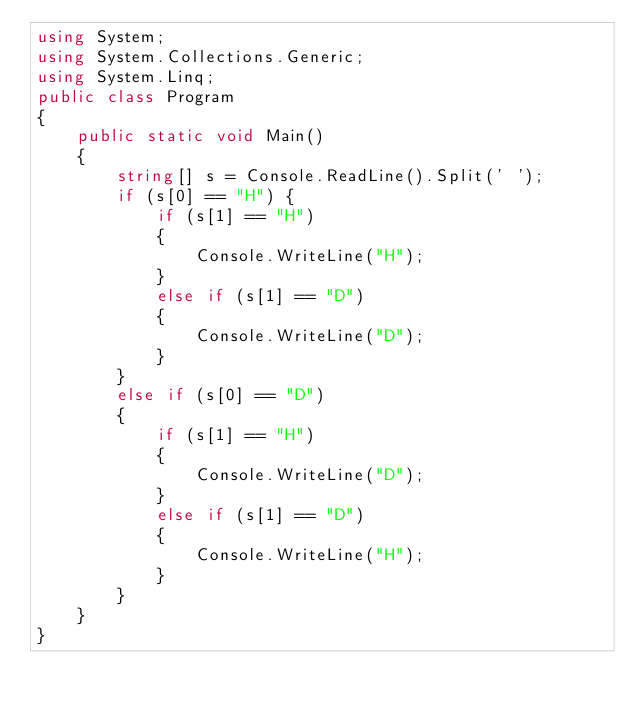<code> <loc_0><loc_0><loc_500><loc_500><_C#_>using System;
using System.Collections.Generic;
using System.Linq;
public class Program
{
    public static void Main()
    {
        string[] s = Console.ReadLine().Split(' ');
        if (s[0] == "H") {
            if (s[1] == "H")
            {
                Console.WriteLine("H");
            }
            else if (s[1] == "D")
            {
                Console.WriteLine("D");
            }
        }
        else if (s[0] == "D")
        {
            if (s[1] == "H")
            {
                Console.WriteLine("D");
            }
            else if (s[1] == "D")
            {
                Console.WriteLine("H");
            }
        }
    }
}</code> 